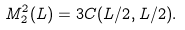<formula> <loc_0><loc_0><loc_500><loc_500>M ^ { 2 } _ { 2 } ( L ) = 3 C ( L / 2 , L / 2 ) .</formula> 